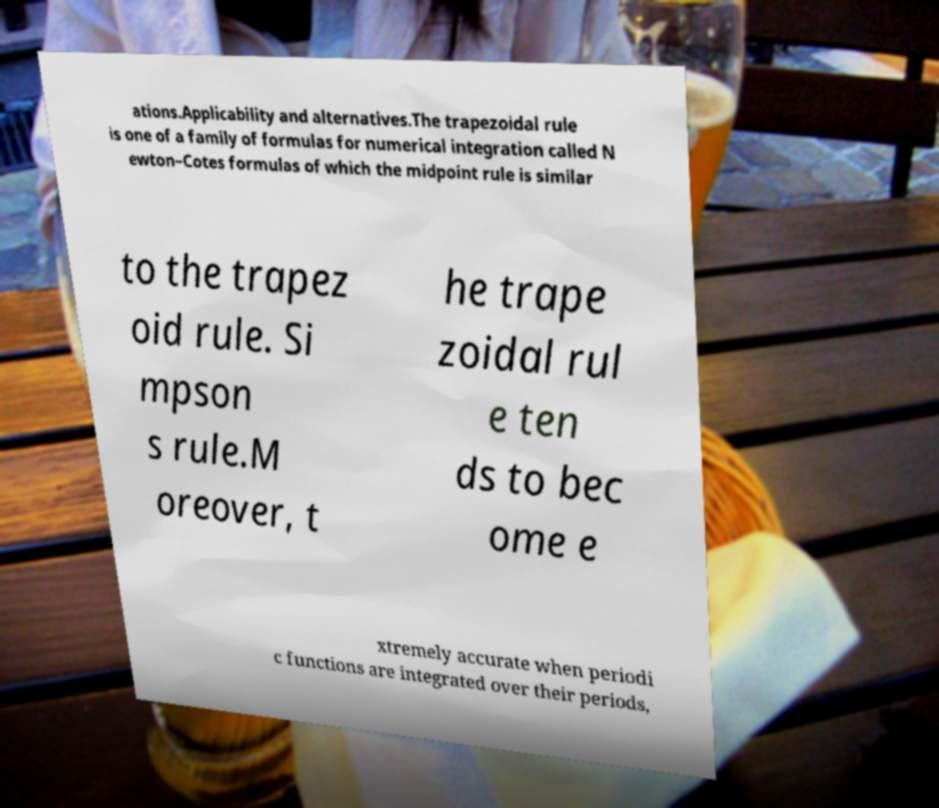What messages or text are displayed in this image? I need them in a readable, typed format. ations.Applicability and alternatives.The trapezoidal rule is one of a family of formulas for numerical integration called N ewton–Cotes formulas of which the midpoint rule is similar to the trapez oid rule. Si mpson s rule.M oreover, t he trape zoidal rul e ten ds to bec ome e xtremely accurate when periodi c functions are integrated over their periods, 